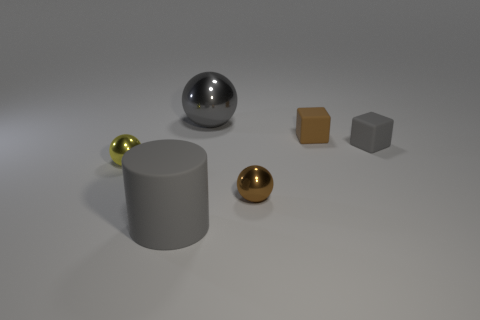Add 1 yellow cylinders. How many objects exist? 7 Subtract all blocks. How many objects are left? 4 Subtract 1 gray cubes. How many objects are left? 5 Subtract all large gray matte cylinders. Subtract all large gray matte objects. How many objects are left? 4 Add 4 yellow metallic spheres. How many yellow metallic spheres are left? 5 Add 4 big brown metal spheres. How many big brown metal spheres exist? 4 